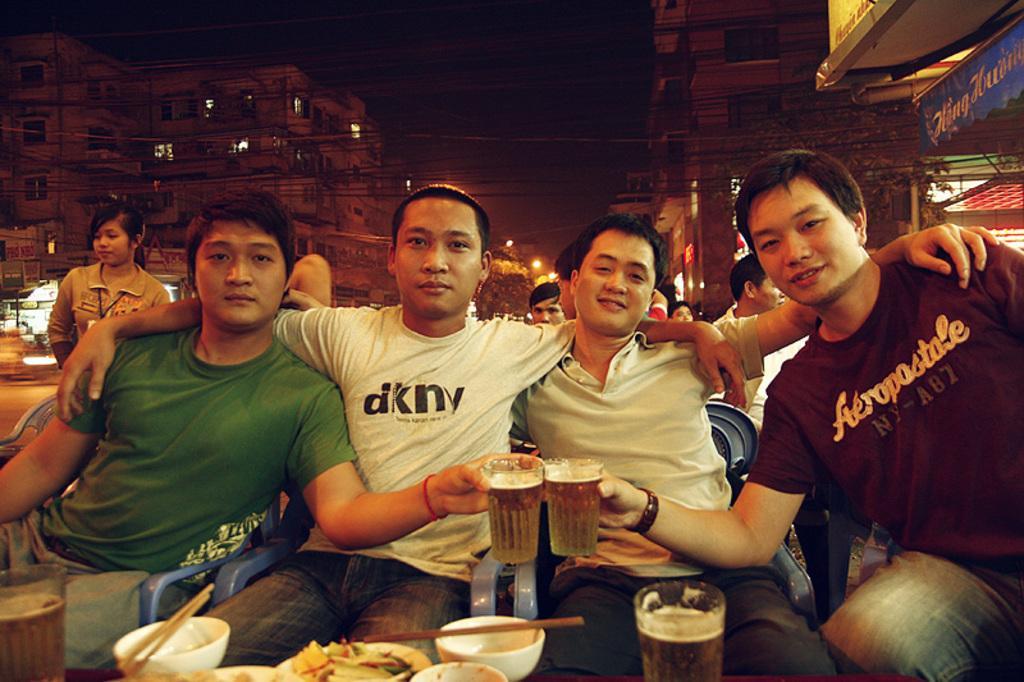Describe this image in one or two sentences. This picture shows four people seated on the chairs and we see a woman Standing on their back and we see few buildings and we see glasses in their hand and few bowls on the table. 